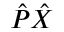<formula> <loc_0><loc_0><loc_500><loc_500>{ \hat { P } } { \hat { X } }</formula> 